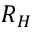<formula> <loc_0><loc_0><loc_500><loc_500>R _ { H }</formula> 